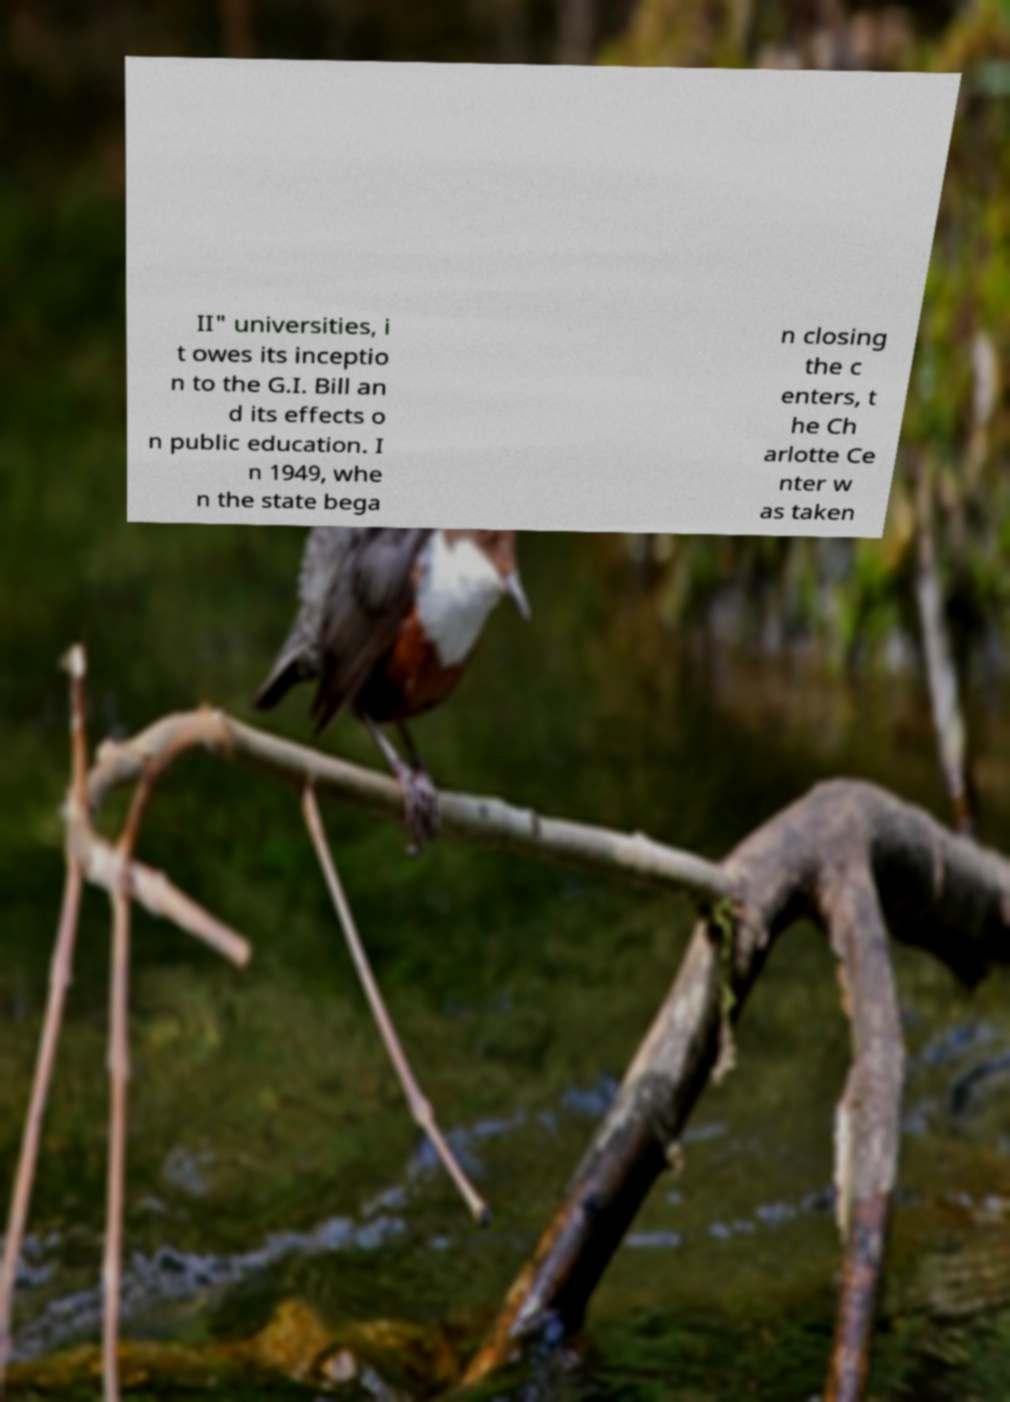Please read and relay the text visible in this image. What does it say? II" universities, i t owes its inceptio n to the G.I. Bill an d its effects o n public education. I n 1949, whe n the state bega n closing the c enters, t he Ch arlotte Ce nter w as taken 